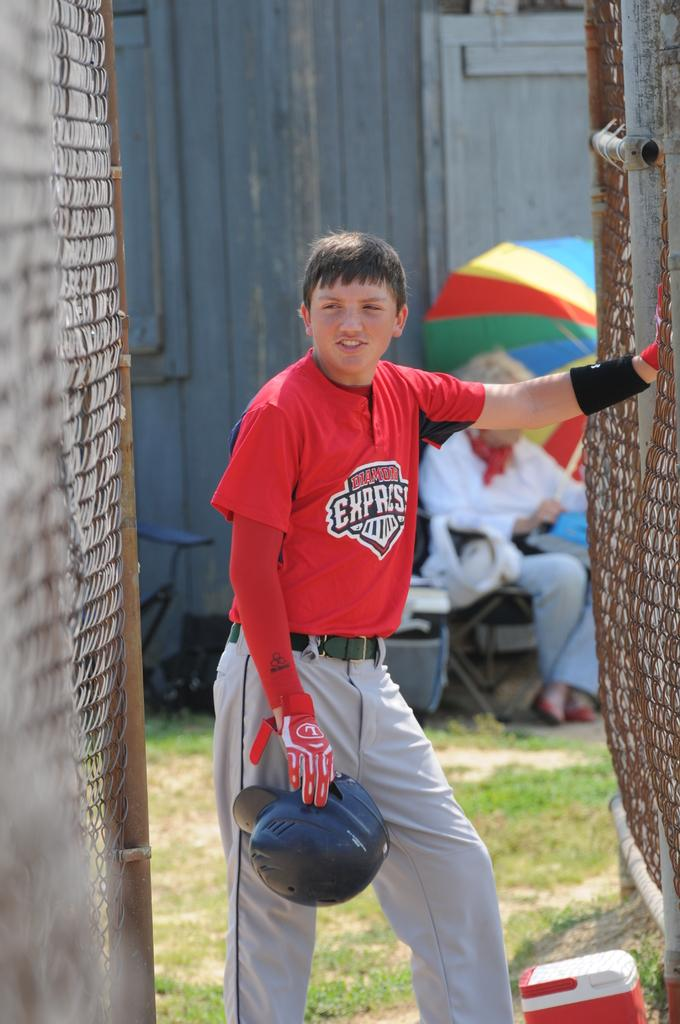<image>
Render a clear and concise summary of the photo. A baseball player holding his helmet wearing a read Diamond Express jersey with a lady under an umbrella in the background. 